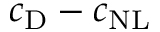<formula> <loc_0><loc_0><loc_500><loc_500>c _ { D } - c _ { N L }</formula> 